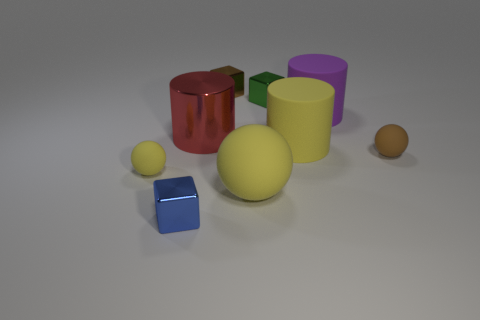Add 1 brown matte balls. How many objects exist? 10 Subtract all blocks. How many objects are left? 6 Subtract all big red shiny cylinders. Subtract all large green metallic cubes. How many objects are left? 8 Add 1 tiny blue metal cubes. How many tiny blue metal cubes are left? 2 Add 8 big red metal objects. How many big red metal objects exist? 9 Subtract 0 green spheres. How many objects are left? 9 